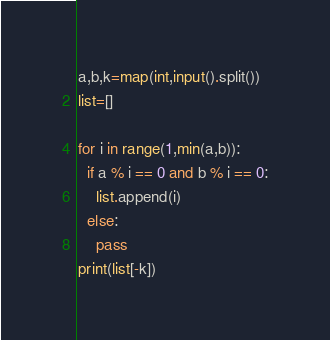<code> <loc_0><loc_0><loc_500><loc_500><_Python_>a,b,k=map(int,input().split())
list=[]

for i in range(1,min(a,b)):
  if a % i == 0 and b % i == 0:
    list.append(i)
  else:
    pass
print(list[-k])</code> 